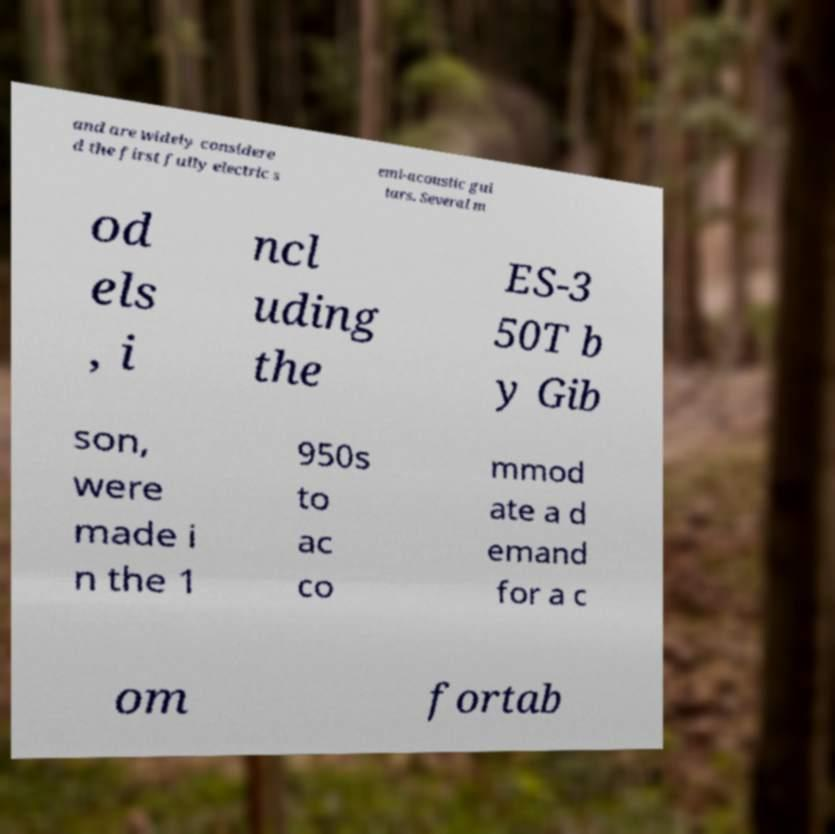Could you assist in decoding the text presented in this image and type it out clearly? and are widely considere d the first fully electric s emi-acoustic gui tars. Several m od els , i ncl uding the ES-3 50T b y Gib son, were made i n the 1 950s to ac co mmod ate a d emand for a c om fortab 